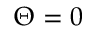<formula> <loc_0><loc_0><loc_500><loc_500>\Theta = 0</formula> 